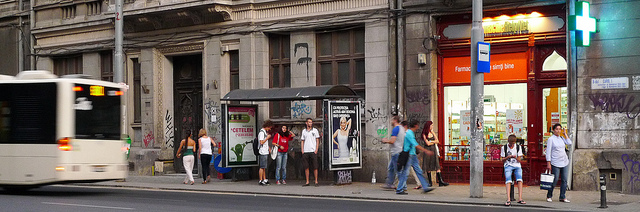Identify the text displayed in this image. 7 WHY? 